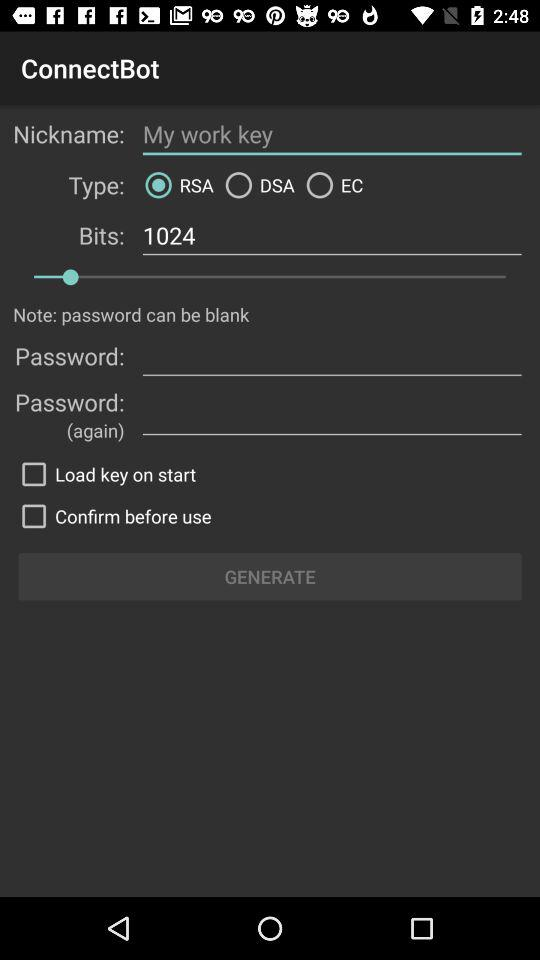What is the nickname? The nickname is "My work key". 